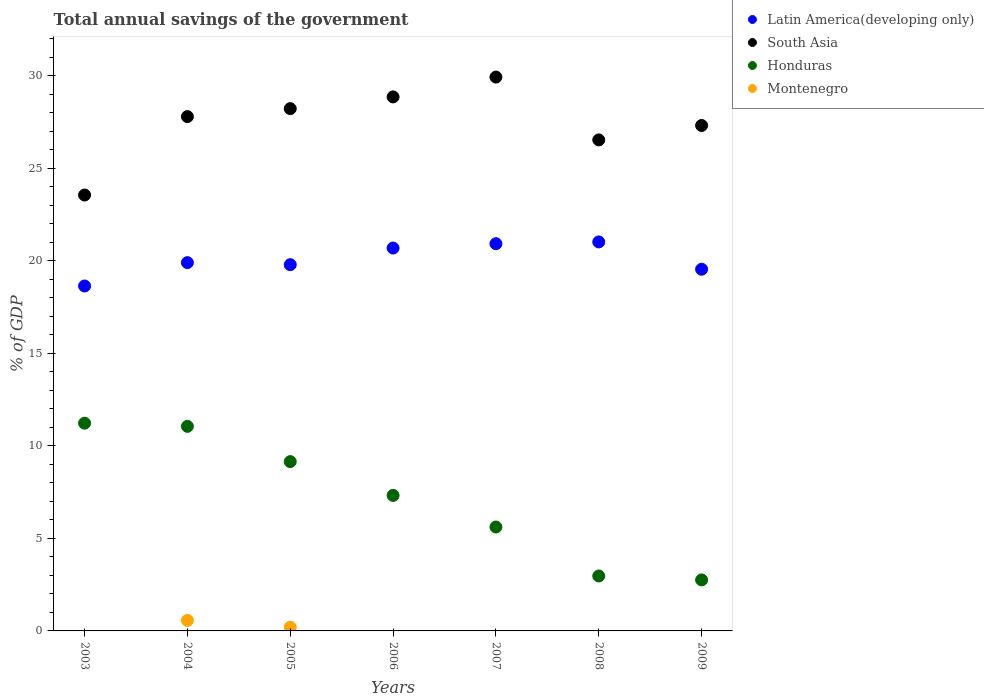How many different coloured dotlines are there?
Ensure brevity in your answer.  4. Across all years, what is the maximum total annual savings of the government in Montenegro?
Provide a succinct answer. 0.57. Across all years, what is the minimum total annual savings of the government in Honduras?
Keep it short and to the point. 2.75. What is the total total annual savings of the government in Latin America(developing only) in the graph?
Give a very brief answer. 140.45. What is the difference between the total annual savings of the government in Honduras in 2004 and that in 2007?
Your answer should be very brief. 5.44. What is the difference between the total annual savings of the government in Montenegro in 2004 and the total annual savings of the government in Honduras in 2003?
Give a very brief answer. -10.66. What is the average total annual savings of the government in Latin America(developing only) per year?
Give a very brief answer. 20.06. In the year 2009, what is the difference between the total annual savings of the government in Latin America(developing only) and total annual savings of the government in Honduras?
Keep it short and to the point. 16.78. What is the ratio of the total annual savings of the government in Honduras in 2007 to that in 2009?
Offer a very short reply. 2.04. Is the difference between the total annual savings of the government in Latin America(developing only) in 2005 and 2007 greater than the difference between the total annual savings of the government in Honduras in 2005 and 2007?
Provide a short and direct response. No. What is the difference between the highest and the second highest total annual savings of the government in Honduras?
Give a very brief answer. 0.17. What is the difference between the highest and the lowest total annual savings of the government in South Asia?
Ensure brevity in your answer.  6.37. In how many years, is the total annual savings of the government in Latin America(developing only) greater than the average total annual savings of the government in Latin America(developing only) taken over all years?
Your answer should be compact. 3. Is it the case that in every year, the sum of the total annual savings of the government in Latin America(developing only) and total annual savings of the government in South Asia  is greater than the sum of total annual savings of the government in Montenegro and total annual savings of the government in Honduras?
Your response must be concise. Yes. Is the total annual savings of the government in Montenegro strictly less than the total annual savings of the government in Latin America(developing only) over the years?
Provide a short and direct response. Yes. How many dotlines are there?
Your answer should be compact. 4. Are the values on the major ticks of Y-axis written in scientific E-notation?
Provide a short and direct response. No. Where does the legend appear in the graph?
Your answer should be very brief. Top right. What is the title of the graph?
Provide a succinct answer. Total annual savings of the government. Does "Uganda" appear as one of the legend labels in the graph?
Give a very brief answer. No. What is the label or title of the Y-axis?
Offer a terse response. % of GDP. What is the % of GDP of Latin America(developing only) in 2003?
Offer a terse response. 18.63. What is the % of GDP in South Asia in 2003?
Ensure brevity in your answer.  23.54. What is the % of GDP of Honduras in 2003?
Ensure brevity in your answer.  11.22. What is the % of GDP in Montenegro in 2003?
Your response must be concise. 0. What is the % of GDP in Latin America(developing only) in 2004?
Offer a terse response. 19.89. What is the % of GDP of South Asia in 2004?
Offer a very short reply. 27.78. What is the % of GDP in Honduras in 2004?
Offer a terse response. 11.05. What is the % of GDP in Montenegro in 2004?
Provide a succinct answer. 0.57. What is the % of GDP of Latin America(developing only) in 2005?
Your answer should be compact. 19.78. What is the % of GDP of South Asia in 2005?
Your response must be concise. 28.21. What is the % of GDP of Honduras in 2005?
Provide a succinct answer. 9.14. What is the % of GDP in Montenegro in 2005?
Make the answer very short. 0.2. What is the % of GDP of Latin America(developing only) in 2006?
Ensure brevity in your answer.  20.68. What is the % of GDP of South Asia in 2006?
Provide a short and direct response. 28.84. What is the % of GDP of Honduras in 2006?
Ensure brevity in your answer.  7.32. What is the % of GDP in Montenegro in 2006?
Your answer should be very brief. 0. What is the % of GDP in Latin America(developing only) in 2007?
Give a very brief answer. 20.92. What is the % of GDP of South Asia in 2007?
Offer a very short reply. 29.92. What is the % of GDP in Honduras in 2007?
Give a very brief answer. 5.61. What is the % of GDP of Montenegro in 2007?
Offer a very short reply. 0. What is the % of GDP of Latin America(developing only) in 2008?
Make the answer very short. 21.01. What is the % of GDP in South Asia in 2008?
Your answer should be very brief. 26.52. What is the % of GDP in Honduras in 2008?
Your answer should be compact. 2.97. What is the % of GDP in Montenegro in 2008?
Your answer should be compact. 0. What is the % of GDP of Latin America(developing only) in 2009?
Your answer should be very brief. 19.54. What is the % of GDP of South Asia in 2009?
Provide a succinct answer. 27.3. What is the % of GDP in Honduras in 2009?
Offer a very short reply. 2.75. What is the % of GDP of Montenegro in 2009?
Offer a very short reply. 0. Across all years, what is the maximum % of GDP in Latin America(developing only)?
Your response must be concise. 21.01. Across all years, what is the maximum % of GDP in South Asia?
Keep it short and to the point. 29.92. Across all years, what is the maximum % of GDP in Honduras?
Ensure brevity in your answer.  11.22. Across all years, what is the maximum % of GDP in Montenegro?
Make the answer very short. 0.57. Across all years, what is the minimum % of GDP of Latin America(developing only)?
Ensure brevity in your answer.  18.63. Across all years, what is the minimum % of GDP of South Asia?
Your answer should be compact. 23.54. Across all years, what is the minimum % of GDP of Honduras?
Provide a succinct answer. 2.75. What is the total % of GDP in Latin America(developing only) in the graph?
Your answer should be compact. 140.45. What is the total % of GDP in South Asia in the graph?
Your answer should be very brief. 192.12. What is the total % of GDP of Honduras in the graph?
Your response must be concise. 50.07. What is the total % of GDP of Montenegro in the graph?
Keep it short and to the point. 0.77. What is the difference between the % of GDP in Latin America(developing only) in 2003 and that in 2004?
Your answer should be very brief. -1.26. What is the difference between the % of GDP of South Asia in 2003 and that in 2004?
Give a very brief answer. -4.24. What is the difference between the % of GDP in Honduras in 2003 and that in 2004?
Make the answer very short. 0.17. What is the difference between the % of GDP in Latin America(developing only) in 2003 and that in 2005?
Keep it short and to the point. -1.15. What is the difference between the % of GDP of South Asia in 2003 and that in 2005?
Make the answer very short. -4.67. What is the difference between the % of GDP in Honduras in 2003 and that in 2005?
Ensure brevity in your answer.  2.08. What is the difference between the % of GDP in Latin America(developing only) in 2003 and that in 2006?
Offer a very short reply. -2.05. What is the difference between the % of GDP in South Asia in 2003 and that in 2006?
Ensure brevity in your answer.  -5.3. What is the difference between the % of GDP of Honduras in 2003 and that in 2006?
Provide a short and direct response. 3.9. What is the difference between the % of GDP of Latin America(developing only) in 2003 and that in 2007?
Ensure brevity in your answer.  -2.29. What is the difference between the % of GDP of South Asia in 2003 and that in 2007?
Offer a terse response. -6.37. What is the difference between the % of GDP of Honduras in 2003 and that in 2007?
Ensure brevity in your answer.  5.61. What is the difference between the % of GDP of Latin America(developing only) in 2003 and that in 2008?
Provide a succinct answer. -2.38. What is the difference between the % of GDP in South Asia in 2003 and that in 2008?
Give a very brief answer. -2.98. What is the difference between the % of GDP of Honduras in 2003 and that in 2008?
Make the answer very short. 8.25. What is the difference between the % of GDP of Latin America(developing only) in 2003 and that in 2009?
Keep it short and to the point. -0.91. What is the difference between the % of GDP of South Asia in 2003 and that in 2009?
Provide a short and direct response. -3.76. What is the difference between the % of GDP of Honduras in 2003 and that in 2009?
Your answer should be very brief. 8.47. What is the difference between the % of GDP in Latin America(developing only) in 2004 and that in 2005?
Provide a short and direct response. 0.11. What is the difference between the % of GDP of South Asia in 2004 and that in 2005?
Your response must be concise. -0.43. What is the difference between the % of GDP of Honduras in 2004 and that in 2005?
Offer a terse response. 1.9. What is the difference between the % of GDP in Montenegro in 2004 and that in 2005?
Keep it short and to the point. 0.37. What is the difference between the % of GDP in Latin America(developing only) in 2004 and that in 2006?
Keep it short and to the point. -0.79. What is the difference between the % of GDP of South Asia in 2004 and that in 2006?
Make the answer very short. -1.06. What is the difference between the % of GDP in Honduras in 2004 and that in 2006?
Your response must be concise. 3.73. What is the difference between the % of GDP of Latin America(developing only) in 2004 and that in 2007?
Ensure brevity in your answer.  -1.02. What is the difference between the % of GDP in South Asia in 2004 and that in 2007?
Your response must be concise. -2.13. What is the difference between the % of GDP of Honduras in 2004 and that in 2007?
Your response must be concise. 5.44. What is the difference between the % of GDP of Latin America(developing only) in 2004 and that in 2008?
Keep it short and to the point. -1.12. What is the difference between the % of GDP in South Asia in 2004 and that in 2008?
Your answer should be very brief. 1.26. What is the difference between the % of GDP in Honduras in 2004 and that in 2008?
Offer a terse response. 8.08. What is the difference between the % of GDP in Latin America(developing only) in 2004 and that in 2009?
Ensure brevity in your answer.  0.36. What is the difference between the % of GDP of South Asia in 2004 and that in 2009?
Provide a short and direct response. 0.48. What is the difference between the % of GDP of Honduras in 2004 and that in 2009?
Provide a short and direct response. 8.29. What is the difference between the % of GDP in Latin America(developing only) in 2005 and that in 2006?
Keep it short and to the point. -0.9. What is the difference between the % of GDP in South Asia in 2005 and that in 2006?
Keep it short and to the point. -0.63. What is the difference between the % of GDP in Honduras in 2005 and that in 2006?
Provide a succinct answer. 1.83. What is the difference between the % of GDP in Latin America(developing only) in 2005 and that in 2007?
Your answer should be very brief. -1.13. What is the difference between the % of GDP in South Asia in 2005 and that in 2007?
Your answer should be compact. -1.7. What is the difference between the % of GDP of Honduras in 2005 and that in 2007?
Keep it short and to the point. 3.53. What is the difference between the % of GDP in Latin America(developing only) in 2005 and that in 2008?
Make the answer very short. -1.23. What is the difference between the % of GDP in South Asia in 2005 and that in 2008?
Your answer should be very brief. 1.69. What is the difference between the % of GDP in Honduras in 2005 and that in 2008?
Offer a terse response. 6.18. What is the difference between the % of GDP of Latin America(developing only) in 2005 and that in 2009?
Ensure brevity in your answer.  0.25. What is the difference between the % of GDP in South Asia in 2005 and that in 2009?
Your answer should be very brief. 0.91. What is the difference between the % of GDP of Honduras in 2005 and that in 2009?
Ensure brevity in your answer.  6.39. What is the difference between the % of GDP in Latin America(developing only) in 2006 and that in 2007?
Ensure brevity in your answer.  -0.24. What is the difference between the % of GDP of South Asia in 2006 and that in 2007?
Provide a succinct answer. -1.07. What is the difference between the % of GDP in Honduras in 2006 and that in 2007?
Your response must be concise. 1.71. What is the difference between the % of GDP in Latin America(developing only) in 2006 and that in 2008?
Provide a short and direct response. -0.33. What is the difference between the % of GDP of South Asia in 2006 and that in 2008?
Give a very brief answer. 2.32. What is the difference between the % of GDP of Honduras in 2006 and that in 2008?
Offer a very short reply. 4.35. What is the difference between the % of GDP in Latin America(developing only) in 2006 and that in 2009?
Keep it short and to the point. 1.14. What is the difference between the % of GDP in South Asia in 2006 and that in 2009?
Your answer should be compact. 1.54. What is the difference between the % of GDP of Honduras in 2006 and that in 2009?
Offer a very short reply. 4.56. What is the difference between the % of GDP of Latin America(developing only) in 2007 and that in 2008?
Provide a succinct answer. -0.1. What is the difference between the % of GDP of South Asia in 2007 and that in 2008?
Provide a short and direct response. 3.39. What is the difference between the % of GDP of Honduras in 2007 and that in 2008?
Ensure brevity in your answer.  2.65. What is the difference between the % of GDP in Latin America(developing only) in 2007 and that in 2009?
Provide a succinct answer. 1.38. What is the difference between the % of GDP of South Asia in 2007 and that in 2009?
Provide a short and direct response. 2.61. What is the difference between the % of GDP in Honduras in 2007 and that in 2009?
Your answer should be compact. 2.86. What is the difference between the % of GDP of Latin America(developing only) in 2008 and that in 2009?
Offer a very short reply. 1.48. What is the difference between the % of GDP of South Asia in 2008 and that in 2009?
Make the answer very short. -0.78. What is the difference between the % of GDP in Honduras in 2008 and that in 2009?
Your response must be concise. 0.21. What is the difference between the % of GDP of Latin America(developing only) in 2003 and the % of GDP of South Asia in 2004?
Make the answer very short. -9.15. What is the difference between the % of GDP of Latin America(developing only) in 2003 and the % of GDP of Honduras in 2004?
Make the answer very short. 7.58. What is the difference between the % of GDP in Latin America(developing only) in 2003 and the % of GDP in Montenegro in 2004?
Offer a very short reply. 18.07. What is the difference between the % of GDP of South Asia in 2003 and the % of GDP of Honduras in 2004?
Keep it short and to the point. 12.49. What is the difference between the % of GDP of South Asia in 2003 and the % of GDP of Montenegro in 2004?
Your answer should be compact. 22.98. What is the difference between the % of GDP of Honduras in 2003 and the % of GDP of Montenegro in 2004?
Your answer should be compact. 10.66. What is the difference between the % of GDP in Latin America(developing only) in 2003 and the % of GDP in South Asia in 2005?
Give a very brief answer. -9.58. What is the difference between the % of GDP of Latin America(developing only) in 2003 and the % of GDP of Honduras in 2005?
Make the answer very short. 9.49. What is the difference between the % of GDP in Latin America(developing only) in 2003 and the % of GDP in Montenegro in 2005?
Provide a short and direct response. 18.43. What is the difference between the % of GDP in South Asia in 2003 and the % of GDP in Honduras in 2005?
Ensure brevity in your answer.  14.4. What is the difference between the % of GDP of South Asia in 2003 and the % of GDP of Montenegro in 2005?
Give a very brief answer. 23.34. What is the difference between the % of GDP in Honduras in 2003 and the % of GDP in Montenegro in 2005?
Provide a short and direct response. 11.02. What is the difference between the % of GDP of Latin America(developing only) in 2003 and the % of GDP of South Asia in 2006?
Make the answer very short. -10.21. What is the difference between the % of GDP in Latin America(developing only) in 2003 and the % of GDP in Honduras in 2006?
Your response must be concise. 11.31. What is the difference between the % of GDP of South Asia in 2003 and the % of GDP of Honduras in 2006?
Your answer should be compact. 16.23. What is the difference between the % of GDP in Latin America(developing only) in 2003 and the % of GDP in South Asia in 2007?
Your answer should be very brief. -11.28. What is the difference between the % of GDP of Latin America(developing only) in 2003 and the % of GDP of Honduras in 2007?
Offer a very short reply. 13.02. What is the difference between the % of GDP of South Asia in 2003 and the % of GDP of Honduras in 2007?
Provide a succinct answer. 17.93. What is the difference between the % of GDP in Latin America(developing only) in 2003 and the % of GDP in South Asia in 2008?
Keep it short and to the point. -7.89. What is the difference between the % of GDP of Latin America(developing only) in 2003 and the % of GDP of Honduras in 2008?
Offer a terse response. 15.66. What is the difference between the % of GDP of South Asia in 2003 and the % of GDP of Honduras in 2008?
Your answer should be very brief. 20.58. What is the difference between the % of GDP of Latin America(developing only) in 2003 and the % of GDP of South Asia in 2009?
Your response must be concise. -8.67. What is the difference between the % of GDP of Latin America(developing only) in 2003 and the % of GDP of Honduras in 2009?
Give a very brief answer. 15.88. What is the difference between the % of GDP of South Asia in 2003 and the % of GDP of Honduras in 2009?
Your response must be concise. 20.79. What is the difference between the % of GDP in Latin America(developing only) in 2004 and the % of GDP in South Asia in 2005?
Give a very brief answer. -8.32. What is the difference between the % of GDP in Latin America(developing only) in 2004 and the % of GDP in Honduras in 2005?
Your answer should be very brief. 10.75. What is the difference between the % of GDP in Latin America(developing only) in 2004 and the % of GDP in Montenegro in 2005?
Your response must be concise. 19.69. What is the difference between the % of GDP in South Asia in 2004 and the % of GDP in Honduras in 2005?
Your response must be concise. 18.64. What is the difference between the % of GDP in South Asia in 2004 and the % of GDP in Montenegro in 2005?
Offer a very short reply. 27.58. What is the difference between the % of GDP in Honduras in 2004 and the % of GDP in Montenegro in 2005?
Give a very brief answer. 10.85. What is the difference between the % of GDP in Latin America(developing only) in 2004 and the % of GDP in South Asia in 2006?
Keep it short and to the point. -8.95. What is the difference between the % of GDP in Latin America(developing only) in 2004 and the % of GDP in Honduras in 2006?
Ensure brevity in your answer.  12.57. What is the difference between the % of GDP of South Asia in 2004 and the % of GDP of Honduras in 2006?
Keep it short and to the point. 20.46. What is the difference between the % of GDP in Latin America(developing only) in 2004 and the % of GDP in South Asia in 2007?
Provide a succinct answer. -10.02. What is the difference between the % of GDP in Latin America(developing only) in 2004 and the % of GDP in Honduras in 2007?
Your answer should be very brief. 14.28. What is the difference between the % of GDP in South Asia in 2004 and the % of GDP in Honduras in 2007?
Keep it short and to the point. 22.17. What is the difference between the % of GDP in Latin America(developing only) in 2004 and the % of GDP in South Asia in 2008?
Make the answer very short. -6.63. What is the difference between the % of GDP of Latin America(developing only) in 2004 and the % of GDP of Honduras in 2008?
Offer a terse response. 16.93. What is the difference between the % of GDP in South Asia in 2004 and the % of GDP in Honduras in 2008?
Your answer should be very brief. 24.81. What is the difference between the % of GDP in Latin America(developing only) in 2004 and the % of GDP in South Asia in 2009?
Your answer should be compact. -7.41. What is the difference between the % of GDP of Latin America(developing only) in 2004 and the % of GDP of Honduras in 2009?
Provide a succinct answer. 17.14. What is the difference between the % of GDP in South Asia in 2004 and the % of GDP in Honduras in 2009?
Make the answer very short. 25.03. What is the difference between the % of GDP of Latin America(developing only) in 2005 and the % of GDP of South Asia in 2006?
Ensure brevity in your answer.  -9.06. What is the difference between the % of GDP of Latin America(developing only) in 2005 and the % of GDP of Honduras in 2006?
Your answer should be compact. 12.46. What is the difference between the % of GDP of South Asia in 2005 and the % of GDP of Honduras in 2006?
Give a very brief answer. 20.89. What is the difference between the % of GDP in Latin America(developing only) in 2005 and the % of GDP in South Asia in 2007?
Make the answer very short. -10.13. What is the difference between the % of GDP of Latin America(developing only) in 2005 and the % of GDP of Honduras in 2007?
Your response must be concise. 14.17. What is the difference between the % of GDP in South Asia in 2005 and the % of GDP in Honduras in 2007?
Make the answer very short. 22.6. What is the difference between the % of GDP of Latin America(developing only) in 2005 and the % of GDP of South Asia in 2008?
Offer a terse response. -6.74. What is the difference between the % of GDP in Latin America(developing only) in 2005 and the % of GDP in Honduras in 2008?
Offer a terse response. 16.81. What is the difference between the % of GDP of South Asia in 2005 and the % of GDP of Honduras in 2008?
Offer a very short reply. 25.24. What is the difference between the % of GDP of Latin America(developing only) in 2005 and the % of GDP of South Asia in 2009?
Make the answer very short. -7.52. What is the difference between the % of GDP in Latin America(developing only) in 2005 and the % of GDP in Honduras in 2009?
Keep it short and to the point. 17.03. What is the difference between the % of GDP in South Asia in 2005 and the % of GDP in Honduras in 2009?
Provide a succinct answer. 25.46. What is the difference between the % of GDP in Latin America(developing only) in 2006 and the % of GDP in South Asia in 2007?
Offer a very short reply. -9.23. What is the difference between the % of GDP in Latin America(developing only) in 2006 and the % of GDP in Honduras in 2007?
Your answer should be compact. 15.07. What is the difference between the % of GDP of South Asia in 2006 and the % of GDP of Honduras in 2007?
Keep it short and to the point. 23.23. What is the difference between the % of GDP in Latin America(developing only) in 2006 and the % of GDP in South Asia in 2008?
Your response must be concise. -5.84. What is the difference between the % of GDP of Latin America(developing only) in 2006 and the % of GDP of Honduras in 2008?
Your answer should be compact. 17.71. What is the difference between the % of GDP in South Asia in 2006 and the % of GDP in Honduras in 2008?
Provide a succinct answer. 25.88. What is the difference between the % of GDP in Latin America(developing only) in 2006 and the % of GDP in South Asia in 2009?
Provide a succinct answer. -6.62. What is the difference between the % of GDP of Latin America(developing only) in 2006 and the % of GDP of Honduras in 2009?
Offer a terse response. 17.93. What is the difference between the % of GDP in South Asia in 2006 and the % of GDP in Honduras in 2009?
Your answer should be compact. 26.09. What is the difference between the % of GDP in Latin America(developing only) in 2007 and the % of GDP in South Asia in 2008?
Your response must be concise. -5.61. What is the difference between the % of GDP of Latin America(developing only) in 2007 and the % of GDP of Honduras in 2008?
Your answer should be compact. 17.95. What is the difference between the % of GDP in South Asia in 2007 and the % of GDP in Honduras in 2008?
Your answer should be compact. 26.95. What is the difference between the % of GDP of Latin America(developing only) in 2007 and the % of GDP of South Asia in 2009?
Provide a short and direct response. -6.38. What is the difference between the % of GDP of Latin America(developing only) in 2007 and the % of GDP of Honduras in 2009?
Provide a short and direct response. 18.16. What is the difference between the % of GDP of South Asia in 2007 and the % of GDP of Honduras in 2009?
Your answer should be very brief. 27.16. What is the difference between the % of GDP in Latin America(developing only) in 2008 and the % of GDP in South Asia in 2009?
Your response must be concise. -6.29. What is the difference between the % of GDP in Latin America(developing only) in 2008 and the % of GDP in Honduras in 2009?
Offer a terse response. 18.26. What is the difference between the % of GDP in South Asia in 2008 and the % of GDP in Honduras in 2009?
Your answer should be very brief. 23.77. What is the average % of GDP of Latin America(developing only) per year?
Provide a short and direct response. 20.06. What is the average % of GDP in South Asia per year?
Your answer should be very brief. 27.45. What is the average % of GDP in Honduras per year?
Provide a short and direct response. 7.15. What is the average % of GDP in Montenegro per year?
Your response must be concise. 0.11. In the year 2003, what is the difference between the % of GDP of Latin America(developing only) and % of GDP of South Asia?
Your answer should be very brief. -4.91. In the year 2003, what is the difference between the % of GDP of Latin America(developing only) and % of GDP of Honduras?
Keep it short and to the point. 7.41. In the year 2003, what is the difference between the % of GDP in South Asia and % of GDP in Honduras?
Offer a terse response. 12.32. In the year 2004, what is the difference between the % of GDP of Latin America(developing only) and % of GDP of South Asia?
Offer a terse response. -7.89. In the year 2004, what is the difference between the % of GDP in Latin America(developing only) and % of GDP in Honduras?
Offer a very short reply. 8.84. In the year 2004, what is the difference between the % of GDP in Latin America(developing only) and % of GDP in Montenegro?
Your response must be concise. 19.33. In the year 2004, what is the difference between the % of GDP in South Asia and % of GDP in Honduras?
Offer a terse response. 16.73. In the year 2004, what is the difference between the % of GDP in South Asia and % of GDP in Montenegro?
Make the answer very short. 27.22. In the year 2004, what is the difference between the % of GDP of Honduras and % of GDP of Montenegro?
Your answer should be very brief. 10.48. In the year 2005, what is the difference between the % of GDP of Latin America(developing only) and % of GDP of South Asia?
Keep it short and to the point. -8.43. In the year 2005, what is the difference between the % of GDP in Latin America(developing only) and % of GDP in Honduras?
Your answer should be very brief. 10.64. In the year 2005, what is the difference between the % of GDP of Latin America(developing only) and % of GDP of Montenegro?
Provide a succinct answer. 19.58. In the year 2005, what is the difference between the % of GDP in South Asia and % of GDP in Honduras?
Make the answer very short. 19.07. In the year 2005, what is the difference between the % of GDP in South Asia and % of GDP in Montenegro?
Offer a very short reply. 28.01. In the year 2005, what is the difference between the % of GDP of Honduras and % of GDP of Montenegro?
Keep it short and to the point. 8.95. In the year 2006, what is the difference between the % of GDP of Latin America(developing only) and % of GDP of South Asia?
Your answer should be compact. -8.16. In the year 2006, what is the difference between the % of GDP of Latin America(developing only) and % of GDP of Honduras?
Provide a succinct answer. 13.36. In the year 2006, what is the difference between the % of GDP of South Asia and % of GDP of Honduras?
Ensure brevity in your answer.  21.52. In the year 2007, what is the difference between the % of GDP in Latin America(developing only) and % of GDP in South Asia?
Keep it short and to the point. -9. In the year 2007, what is the difference between the % of GDP of Latin America(developing only) and % of GDP of Honduras?
Your response must be concise. 15.3. In the year 2007, what is the difference between the % of GDP of South Asia and % of GDP of Honduras?
Make the answer very short. 24.3. In the year 2008, what is the difference between the % of GDP in Latin America(developing only) and % of GDP in South Asia?
Your response must be concise. -5.51. In the year 2008, what is the difference between the % of GDP of Latin America(developing only) and % of GDP of Honduras?
Offer a terse response. 18.04. In the year 2008, what is the difference between the % of GDP of South Asia and % of GDP of Honduras?
Ensure brevity in your answer.  23.55. In the year 2009, what is the difference between the % of GDP in Latin America(developing only) and % of GDP in South Asia?
Ensure brevity in your answer.  -7.76. In the year 2009, what is the difference between the % of GDP of Latin America(developing only) and % of GDP of Honduras?
Make the answer very short. 16.78. In the year 2009, what is the difference between the % of GDP in South Asia and % of GDP in Honduras?
Give a very brief answer. 24.55. What is the ratio of the % of GDP in Latin America(developing only) in 2003 to that in 2004?
Keep it short and to the point. 0.94. What is the ratio of the % of GDP in South Asia in 2003 to that in 2004?
Make the answer very short. 0.85. What is the ratio of the % of GDP of Honduras in 2003 to that in 2004?
Make the answer very short. 1.02. What is the ratio of the % of GDP in Latin America(developing only) in 2003 to that in 2005?
Offer a terse response. 0.94. What is the ratio of the % of GDP in South Asia in 2003 to that in 2005?
Provide a short and direct response. 0.83. What is the ratio of the % of GDP of Honduras in 2003 to that in 2005?
Offer a terse response. 1.23. What is the ratio of the % of GDP in Latin America(developing only) in 2003 to that in 2006?
Keep it short and to the point. 0.9. What is the ratio of the % of GDP of South Asia in 2003 to that in 2006?
Make the answer very short. 0.82. What is the ratio of the % of GDP in Honduras in 2003 to that in 2006?
Provide a succinct answer. 1.53. What is the ratio of the % of GDP in Latin America(developing only) in 2003 to that in 2007?
Provide a succinct answer. 0.89. What is the ratio of the % of GDP in South Asia in 2003 to that in 2007?
Provide a short and direct response. 0.79. What is the ratio of the % of GDP in Honduras in 2003 to that in 2007?
Your response must be concise. 2. What is the ratio of the % of GDP of Latin America(developing only) in 2003 to that in 2008?
Your response must be concise. 0.89. What is the ratio of the % of GDP in South Asia in 2003 to that in 2008?
Offer a terse response. 0.89. What is the ratio of the % of GDP of Honduras in 2003 to that in 2008?
Provide a short and direct response. 3.78. What is the ratio of the % of GDP in Latin America(developing only) in 2003 to that in 2009?
Offer a terse response. 0.95. What is the ratio of the % of GDP in South Asia in 2003 to that in 2009?
Offer a terse response. 0.86. What is the ratio of the % of GDP in Honduras in 2003 to that in 2009?
Keep it short and to the point. 4.07. What is the ratio of the % of GDP in Latin America(developing only) in 2004 to that in 2005?
Provide a short and direct response. 1.01. What is the ratio of the % of GDP of Honduras in 2004 to that in 2005?
Provide a short and direct response. 1.21. What is the ratio of the % of GDP in Montenegro in 2004 to that in 2005?
Your answer should be very brief. 2.83. What is the ratio of the % of GDP of Latin America(developing only) in 2004 to that in 2006?
Provide a succinct answer. 0.96. What is the ratio of the % of GDP in South Asia in 2004 to that in 2006?
Make the answer very short. 0.96. What is the ratio of the % of GDP in Honduras in 2004 to that in 2006?
Make the answer very short. 1.51. What is the ratio of the % of GDP of Latin America(developing only) in 2004 to that in 2007?
Offer a terse response. 0.95. What is the ratio of the % of GDP of South Asia in 2004 to that in 2007?
Offer a very short reply. 0.93. What is the ratio of the % of GDP of Honduras in 2004 to that in 2007?
Make the answer very short. 1.97. What is the ratio of the % of GDP of Latin America(developing only) in 2004 to that in 2008?
Your answer should be very brief. 0.95. What is the ratio of the % of GDP of South Asia in 2004 to that in 2008?
Your answer should be very brief. 1.05. What is the ratio of the % of GDP of Honduras in 2004 to that in 2008?
Make the answer very short. 3.72. What is the ratio of the % of GDP in Latin America(developing only) in 2004 to that in 2009?
Ensure brevity in your answer.  1.02. What is the ratio of the % of GDP in South Asia in 2004 to that in 2009?
Provide a short and direct response. 1.02. What is the ratio of the % of GDP in Honduras in 2004 to that in 2009?
Provide a short and direct response. 4.01. What is the ratio of the % of GDP in Latin America(developing only) in 2005 to that in 2006?
Your response must be concise. 0.96. What is the ratio of the % of GDP of South Asia in 2005 to that in 2006?
Offer a terse response. 0.98. What is the ratio of the % of GDP of Honduras in 2005 to that in 2006?
Your response must be concise. 1.25. What is the ratio of the % of GDP in Latin America(developing only) in 2005 to that in 2007?
Your answer should be compact. 0.95. What is the ratio of the % of GDP of South Asia in 2005 to that in 2007?
Offer a very short reply. 0.94. What is the ratio of the % of GDP in Honduras in 2005 to that in 2007?
Your answer should be compact. 1.63. What is the ratio of the % of GDP in Latin America(developing only) in 2005 to that in 2008?
Keep it short and to the point. 0.94. What is the ratio of the % of GDP of South Asia in 2005 to that in 2008?
Make the answer very short. 1.06. What is the ratio of the % of GDP in Honduras in 2005 to that in 2008?
Provide a short and direct response. 3.08. What is the ratio of the % of GDP in Latin America(developing only) in 2005 to that in 2009?
Offer a terse response. 1.01. What is the ratio of the % of GDP in South Asia in 2005 to that in 2009?
Ensure brevity in your answer.  1.03. What is the ratio of the % of GDP in Honduras in 2005 to that in 2009?
Offer a terse response. 3.32. What is the ratio of the % of GDP of Latin America(developing only) in 2006 to that in 2007?
Offer a terse response. 0.99. What is the ratio of the % of GDP of South Asia in 2006 to that in 2007?
Ensure brevity in your answer.  0.96. What is the ratio of the % of GDP in Honduras in 2006 to that in 2007?
Your answer should be very brief. 1.3. What is the ratio of the % of GDP in Latin America(developing only) in 2006 to that in 2008?
Offer a terse response. 0.98. What is the ratio of the % of GDP of South Asia in 2006 to that in 2008?
Make the answer very short. 1.09. What is the ratio of the % of GDP of Honduras in 2006 to that in 2008?
Your answer should be compact. 2.47. What is the ratio of the % of GDP of Latin America(developing only) in 2006 to that in 2009?
Provide a short and direct response. 1.06. What is the ratio of the % of GDP in South Asia in 2006 to that in 2009?
Ensure brevity in your answer.  1.06. What is the ratio of the % of GDP in Honduras in 2006 to that in 2009?
Your response must be concise. 2.66. What is the ratio of the % of GDP in Latin America(developing only) in 2007 to that in 2008?
Provide a succinct answer. 1. What is the ratio of the % of GDP in South Asia in 2007 to that in 2008?
Provide a short and direct response. 1.13. What is the ratio of the % of GDP in Honduras in 2007 to that in 2008?
Your answer should be very brief. 1.89. What is the ratio of the % of GDP of Latin America(developing only) in 2007 to that in 2009?
Your answer should be very brief. 1.07. What is the ratio of the % of GDP in South Asia in 2007 to that in 2009?
Your answer should be compact. 1.1. What is the ratio of the % of GDP of Honduras in 2007 to that in 2009?
Provide a short and direct response. 2.04. What is the ratio of the % of GDP in Latin America(developing only) in 2008 to that in 2009?
Make the answer very short. 1.08. What is the ratio of the % of GDP in South Asia in 2008 to that in 2009?
Make the answer very short. 0.97. What is the ratio of the % of GDP in Honduras in 2008 to that in 2009?
Your answer should be very brief. 1.08. What is the difference between the highest and the second highest % of GDP in Latin America(developing only)?
Make the answer very short. 0.1. What is the difference between the highest and the second highest % of GDP in South Asia?
Provide a short and direct response. 1.07. What is the difference between the highest and the second highest % of GDP of Honduras?
Ensure brevity in your answer.  0.17. What is the difference between the highest and the lowest % of GDP in Latin America(developing only)?
Offer a terse response. 2.38. What is the difference between the highest and the lowest % of GDP of South Asia?
Ensure brevity in your answer.  6.37. What is the difference between the highest and the lowest % of GDP in Honduras?
Make the answer very short. 8.47. What is the difference between the highest and the lowest % of GDP of Montenegro?
Make the answer very short. 0.57. 